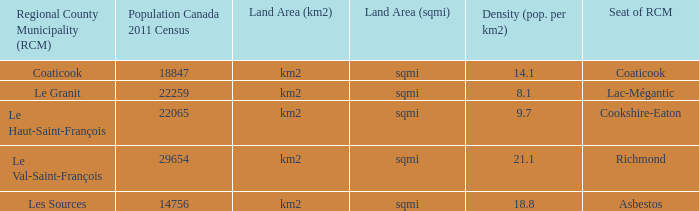What is the RCM that has a density of 9.7? Le Haut-Saint-François. 